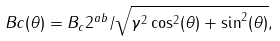<formula> <loc_0><loc_0><loc_500><loc_500>\ B c ( \theta ) = B _ { c } 2 ^ { a b } / \sqrt { \gamma ^ { 2 } \cos ^ { 2 } ( \theta ) + \sin ^ { 2 } ( \theta ) } ,</formula> 